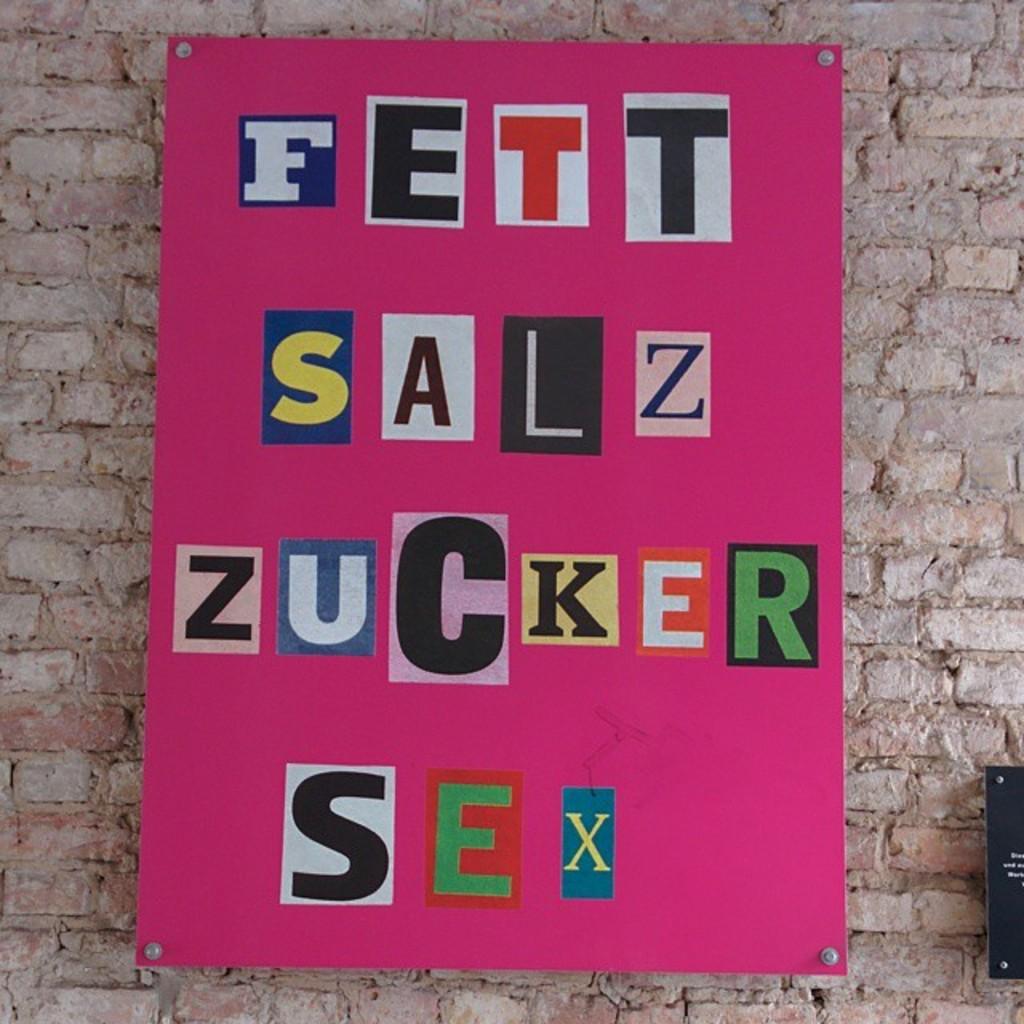What's the 3rd word?
Ensure brevity in your answer.  Zucker. What is the fourth word on the poster?
Ensure brevity in your answer.  Sex. 